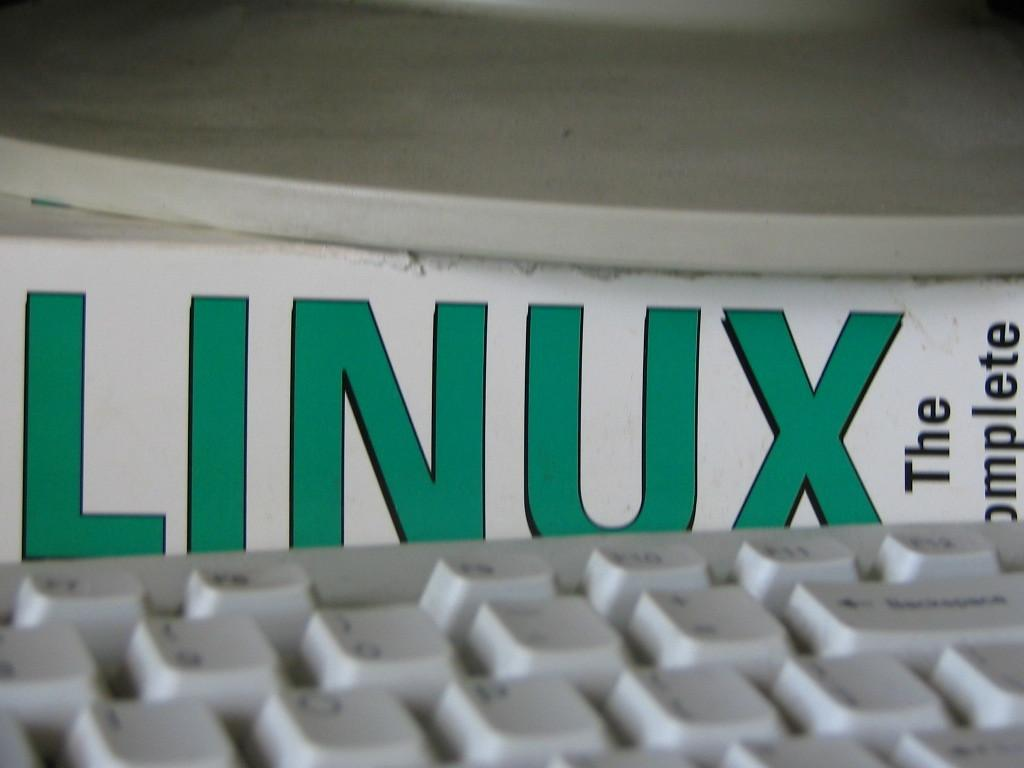What is located at the bottom of the image? There is a white keyboard at the bottom of the image. What can be seen in the middle of the image? There is a white board with text in the image. What object is present at the top of the image? There is a white object that looks like a table on the top of the image. How many tickets are attached to the wire in the image? There is no wire or tickets present in the image. What color is the stocking on the white object in the image? There is no stocking present in the image. 